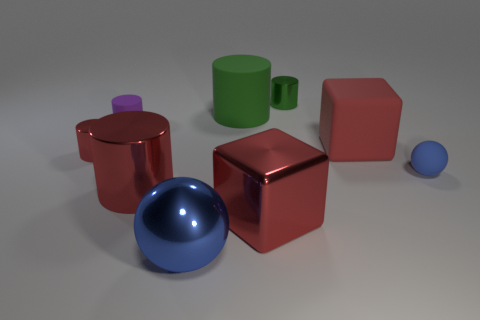What material is the big green cylinder?
Your response must be concise. Rubber. What number of other objects are there of the same color as the big metal cylinder?
Offer a terse response. 3. Is the color of the small matte ball the same as the metal block?
Your answer should be very brief. No. What number of tiny green shiny objects are there?
Offer a terse response. 1. The big red block behind the big cylinder that is in front of the blue rubber sphere is made of what material?
Ensure brevity in your answer.  Rubber. There is a red cylinder that is the same size as the red matte thing; what is it made of?
Give a very brief answer. Metal. Does the blue ball that is to the left of the red rubber thing have the same size as the small red thing?
Make the answer very short. No. Do the blue object that is behind the blue metal ball and the small purple matte object have the same shape?
Provide a short and direct response. No. What number of things are big purple matte cylinders or small metallic cylinders behind the purple thing?
Offer a terse response. 1. Is the number of small purple shiny things less than the number of matte spheres?
Offer a very short reply. Yes. 